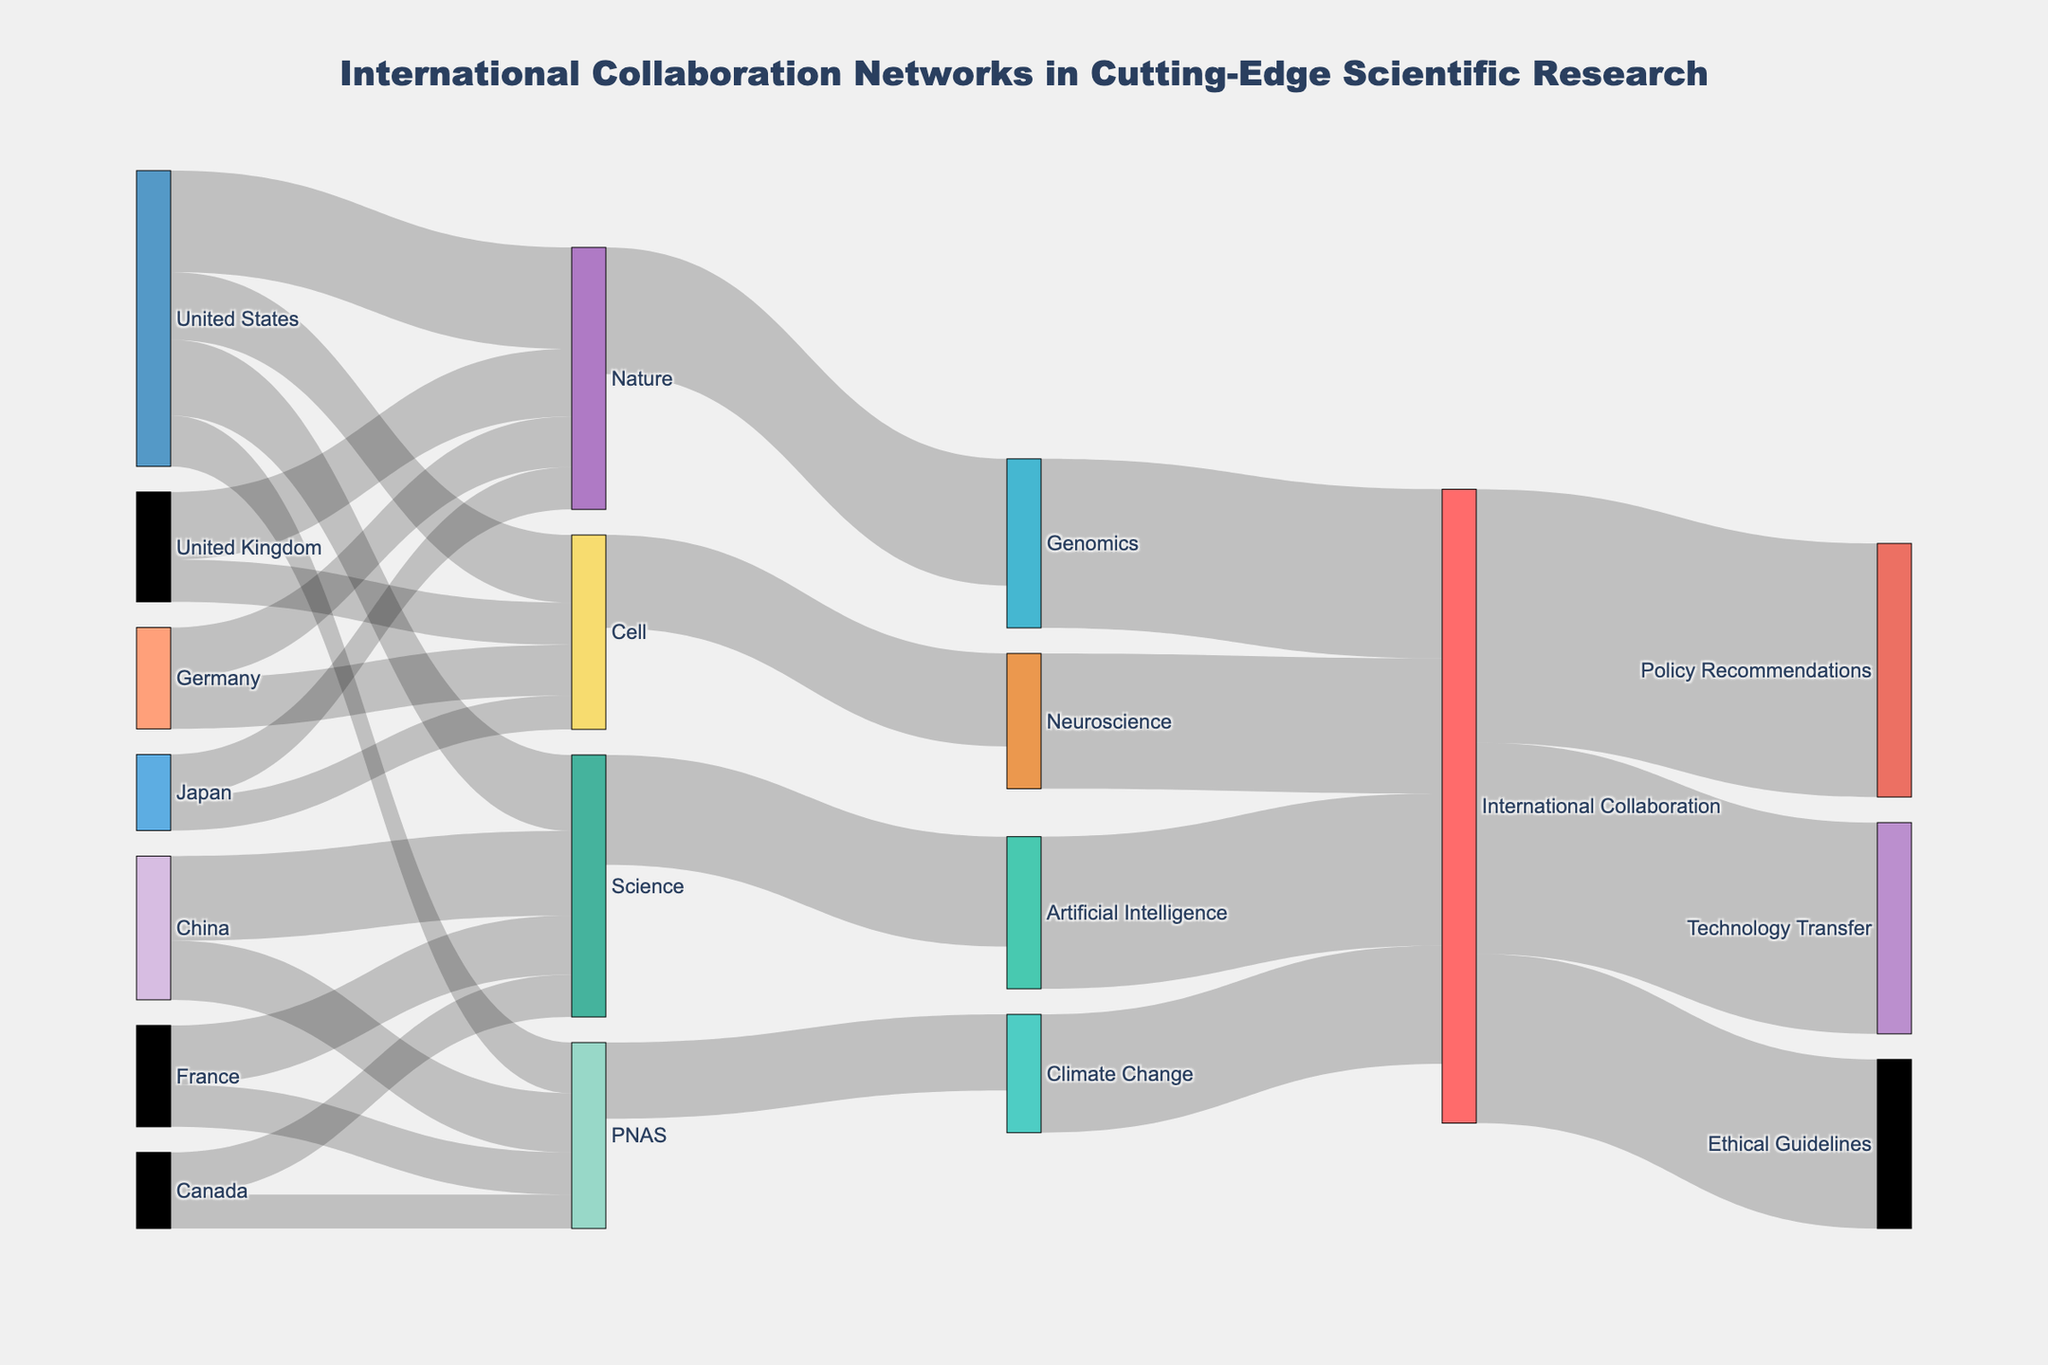What is the title of the figure? The title is positioned at the top center of the figure. It states the main focus of the diagram.
Answer: International Collaboration Networks in Cutting-Edge Scientific Research Which country has the highest value of publications in the journal 'Nature'? Look for the largest value connected to 'Nature'. The United States has a value of 120.
Answer: United States List the cutting-edge research topics covered in the figure. Identify the nodes that denote research topics: Genomics, Artificial Intelligence, Neuroscience, Climate Change.
Answer: Genomics, Artificial Intelligence, Neuroscience, Climate Change What is the total value of international collaboration flowing from 'PNAS'? Sum the values flowing from the node 'PNAS'. Values are Climate Change (90).
Answer: 90 Which publication has the highest value flowing into 'Artificial Intelligence'? Track the flow into 'Artificial Intelligence'. 'Science' flows into it with the highest value of 130.
Answer: Science Compare the total values flowing into the 'Genomics' and 'Neuroscience' sectors. Which one is higher? Calculate the sum of values flowing into 'Genomics' and 'Neuroscience', which have 150 and 110 respectively. Genomics has a higher value.
Answer: Genomics Which type of international collaboration has the highest value? Find the highest value among the collaborations originating from 'International Collaboration'. Policy Recommendations (300).
Answer: Policy Recommendations How many journals contribute to the 'Genomics' research topic? Identify and count the nodes connected directly to 'Genomics'.
Answer: 1 (Nature) What is the combined value of publications by Japan across all journals? Sum Japan's values across Nature (50), Cell (40), and PNAS (0).
Answer: 90 Does 'Technology Transfer' receive more value from 'International Collaboration' than 'Ethical Guidelines'? Compare values from 'International Collaboration' to 'Technology Transfer' (250) and 'Ethical Guidelines' (200).
Answer: Yes 